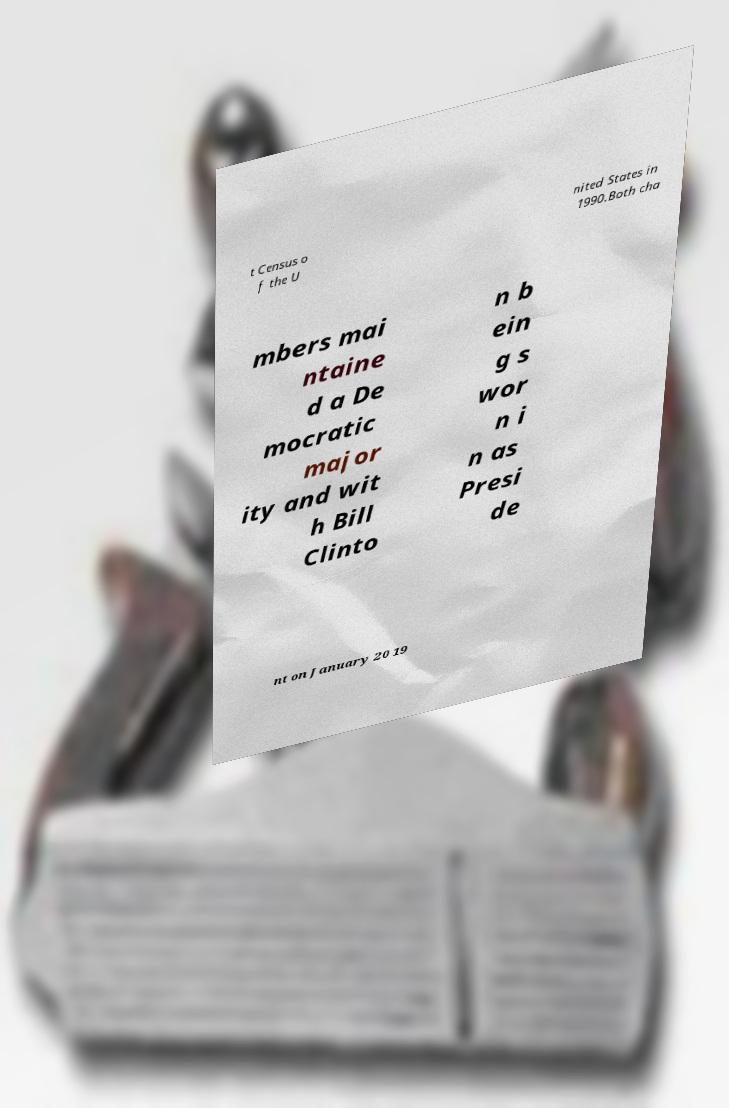I need the written content from this picture converted into text. Can you do that? t Census o f the U nited States in 1990.Both cha mbers mai ntaine d a De mocratic major ity and wit h Bill Clinto n b ein g s wor n i n as Presi de nt on January 20 19 